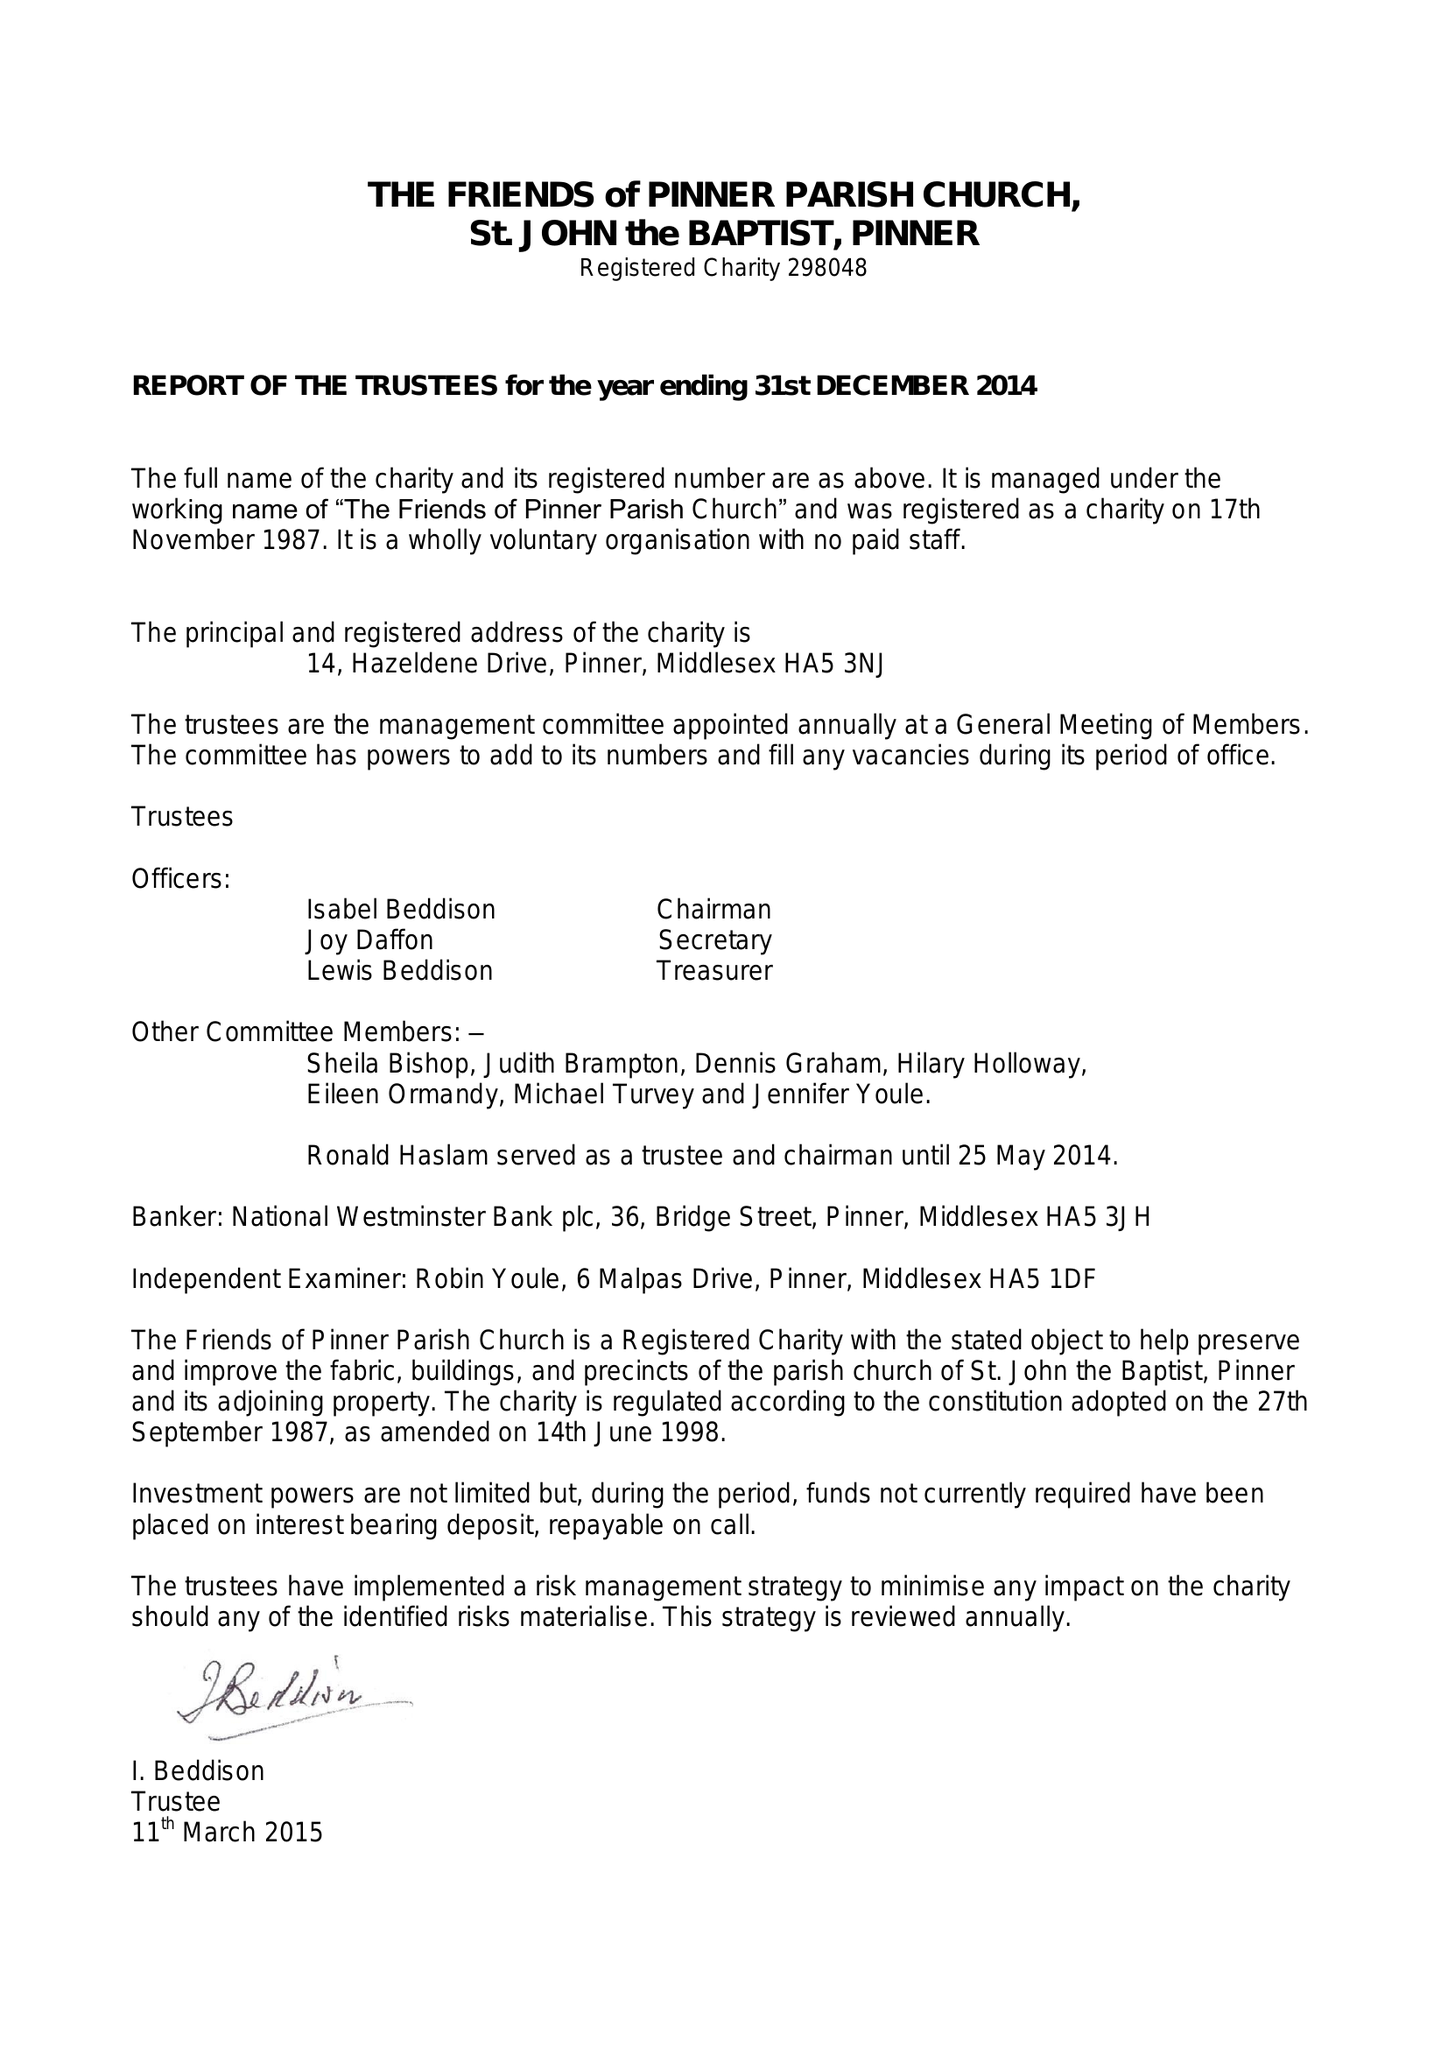What is the value for the address__post_town?
Answer the question using a single word or phrase. PINNER 